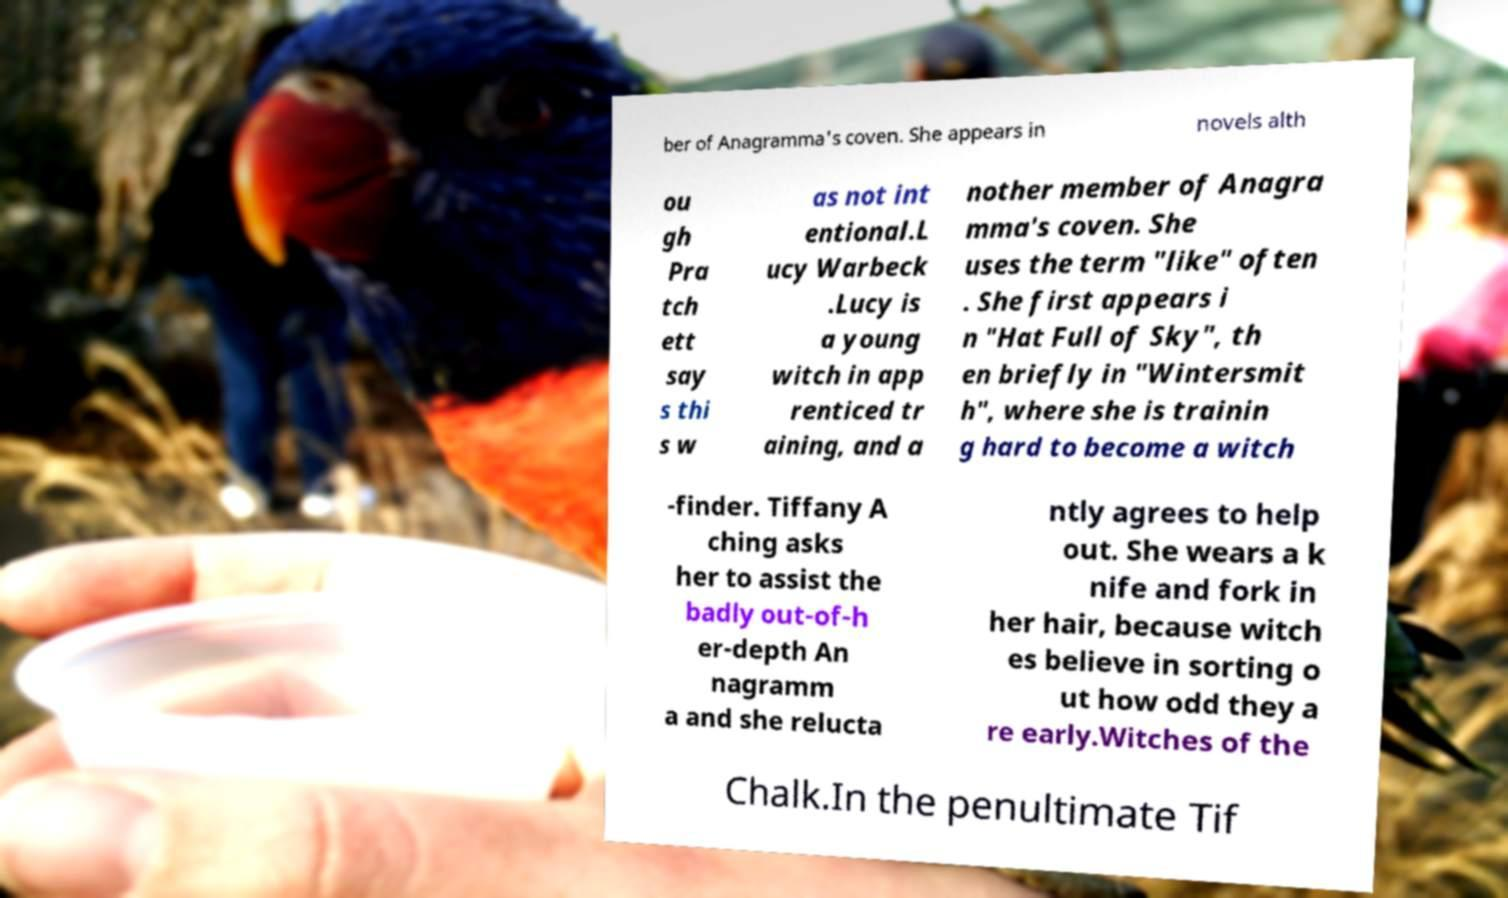For documentation purposes, I need the text within this image transcribed. Could you provide that? ber of Anagramma's coven. She appears in novels alth ou gh Pra tch ett say s thi s w as not int entional.L ucy Warbeck .Lucy is a young witch in app renticed tr aining, and a nother member of Anagra mma's coven. She uses the term "like" often . She first appears i n "Hat Full of Sky", th en briefly in "Wintersmit h", where she is trainin g hard to become a witch -finder. Tiffany A ching asks her to assist the badly out-of-h er-depth An nagramm a and she relucta ntly agrees to help out. She wears a k nife and fork in her hair, because witch es believe in sorting o ut how odd they a re early.Witches of the Chalk.In the penultimate Tif 